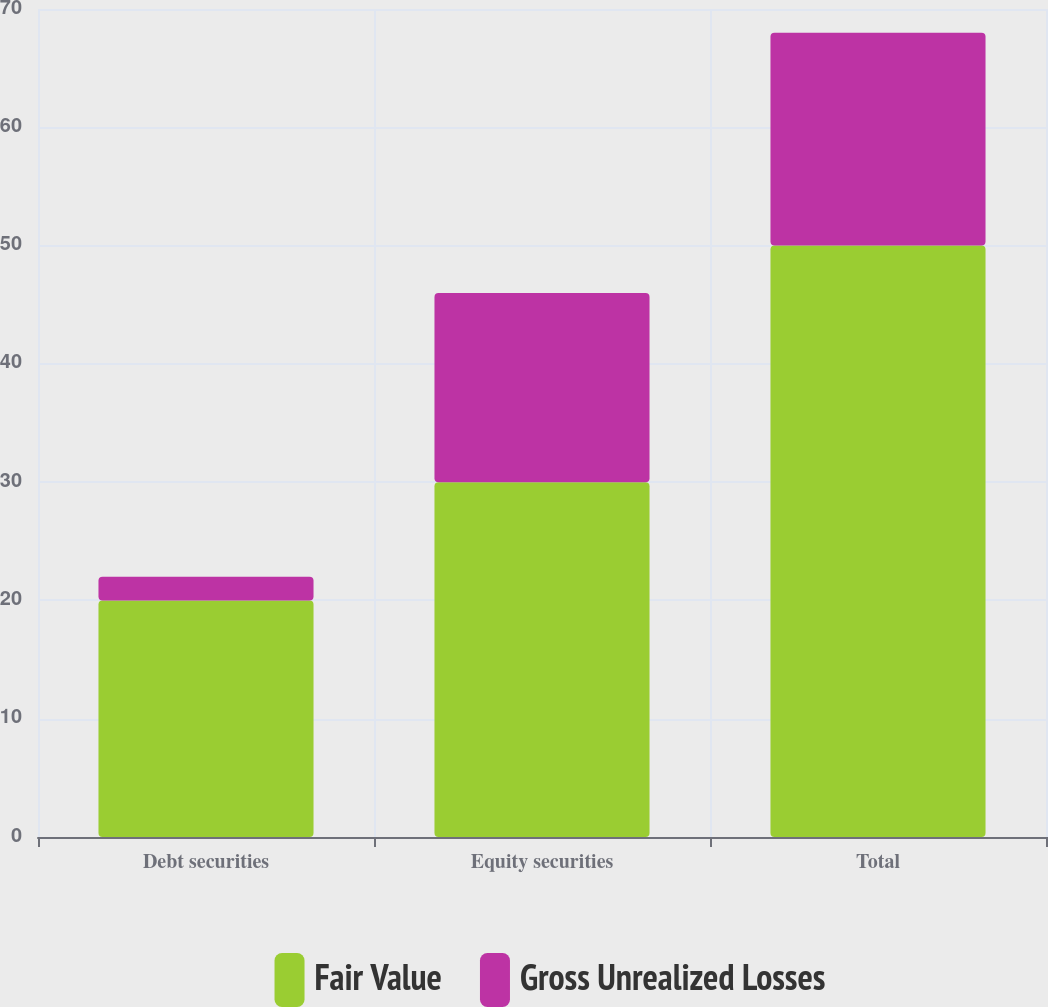<chart> <loc_0><loc_0><loc_500><loc_500><stacked_bar_chart><ecel><fcel>Debt securities<fcel>Equity securities<fcel>Total<nl><fcel>Fair Value<fcel>20<fcel>30<fcel>50<nl><fcel>Gross Unrealized Losses<fcel>2<fcel>16<fcel>18<nl></chart> 